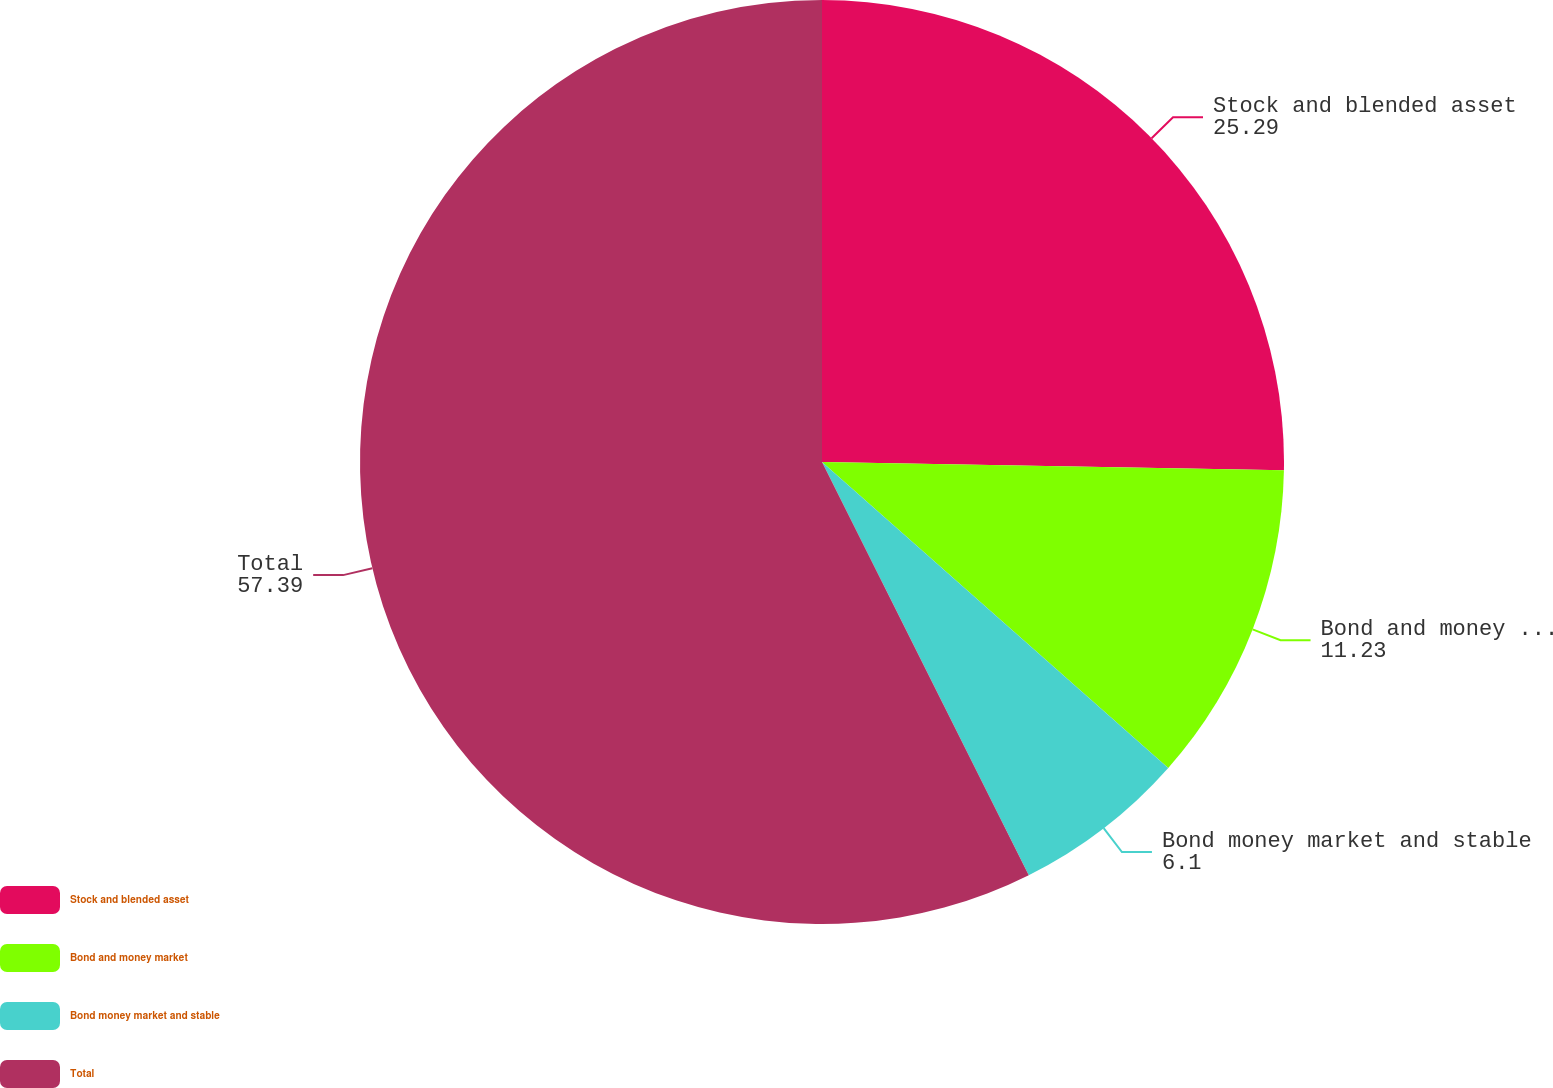Convert chart. <chart><loc_0><loc_0><loc_500><loc_500><pie_chart><fcel>Stock and blended asset<fcel>Bond and money market<fcel>Bond money market and stable<fcel>Total<nl><fcel>25.29%<fcel>11.23%<fcel>6.1%<fcel>57.39%<nl></chart> 